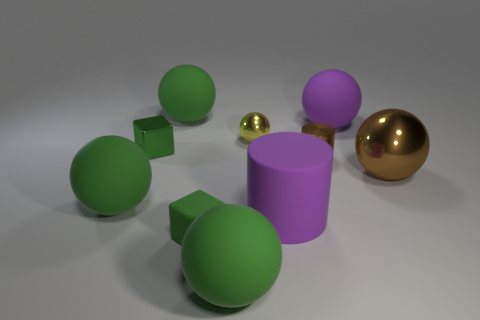Subtract all brown metallic spheres. How many spheres are left? 5 Subtract 3 spheres. How many spheres are left? 3 Subtract all yellow balls. How many balls are left? 5 Add 8 cylinders. How many cylinders exist? 10 Subtract 0 gray spheres. How many objects are left? 10 Subtract all cylinders. How many objects are left? 8 Subtract all red cylinders. Subtract all brown blocks. How many cylinders are left? 2 Subtract all purple spheres. How many purple cylinders are left? 1 Subtract all large cyan objects. Subtract all metal cubes. How many objects are left? 9 Add 9 small rubber things. How many small rubber things are left? 10 